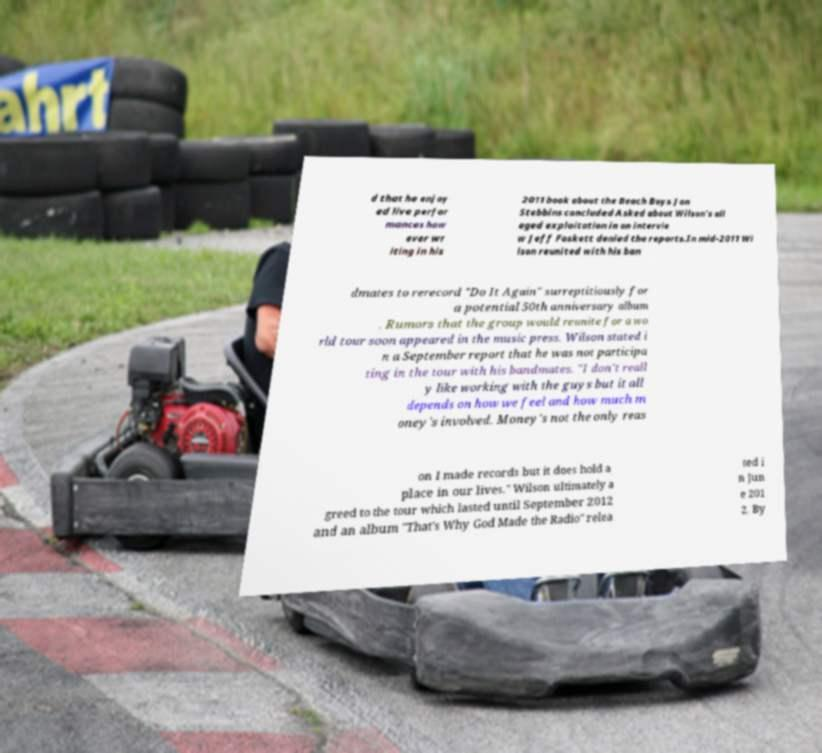I need the written content from this picture converted into text. Can you do that? d that he enjoy ed live perfor mances how ever wr iting in his 2011 book about the Beach Boys Jon Stebbins concluded Asked about Wilson's all eged exploitation in an intervie w Jeff Foskett denied the reports.In mid-2011 Wi lson reunited with his ban dmates to rerecord "Do It Again" surreptitiously for a potential 50th anniversary album . Rumors that the group would reunite for a wo rld tour soon appeared in the music press. Wilson stated i n a September report that he was not participa ting in the tour with his bandmates. "I don't reall y like working with the guys but it all depends on how we feel and how much m oney's involved. Money's not the only reas on I made records but it does hold a place in our lives." Wilson ultimately a greed to the tour which lasted until September 2012 and an album "That's Why God Made the Radio" relea sed i n Jun e 201 2. By 